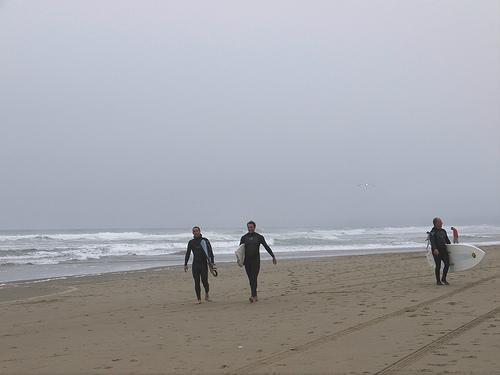How many birds are visible?
Give a very brief answer. 1. 